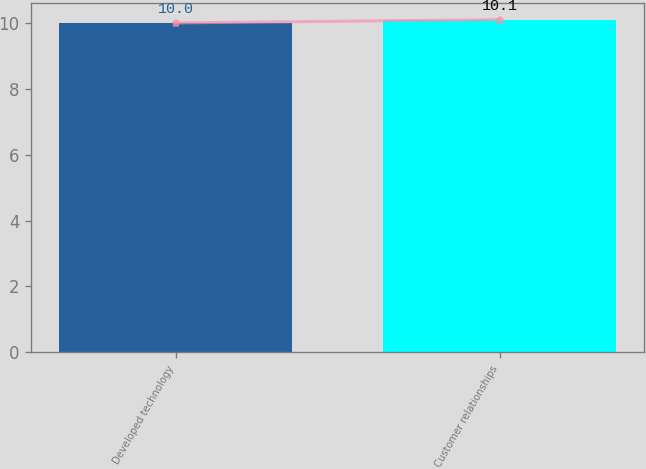Convert chart to OTSL. <chart><loc_0><loc_0><loc_500><loc_500><bar_chart><fcel>Developed technology<fcel>Customer relationships<nl><fcel>10<fcel>10.1<nl></chart> 